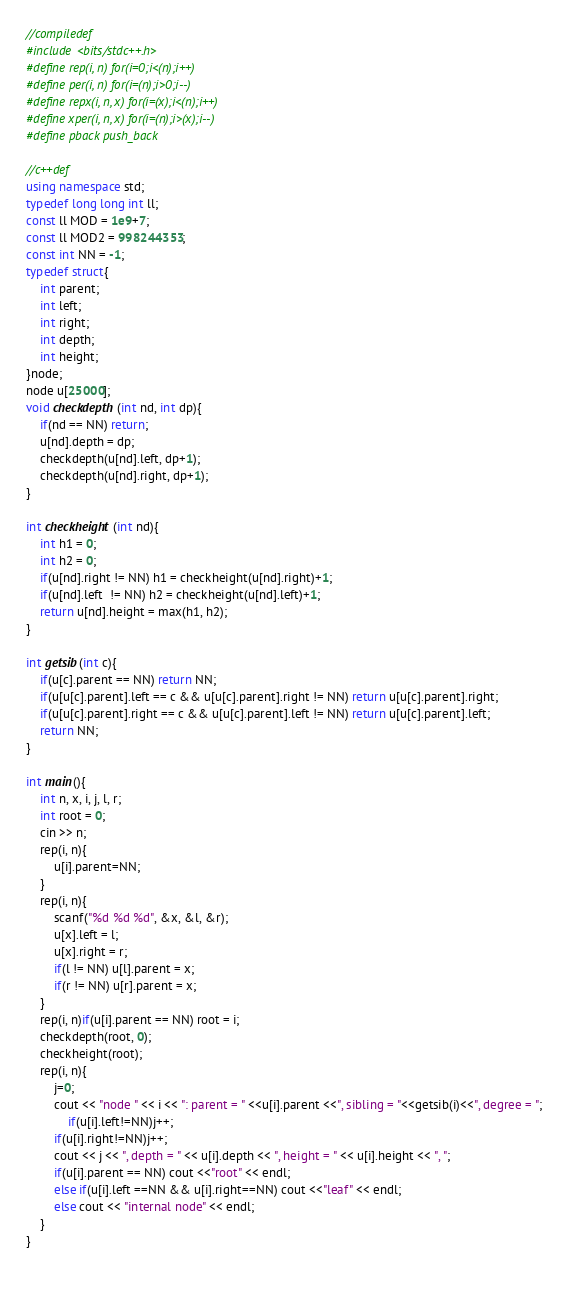Convert code to text. <code><loc_0><loc_0><loc_500><loc_500><_C++_>//compiledef
#include <bits/stdc++.h>
#define rep(i, n) for(i=0;i<(n);i++)
#define per(i, n) for(i=(n);i>0;i--)
#define repx(i, n, x) for(i=(x);i<(n);i++)
#define xper(i, n, x) for(i=(n);i>(x);i--)
#define pback push_back

//c++def
using namespace std;
typedef long long int ll;
const ll MOD = 1e9+7;
const ll MOD2 = 998244353;
const int NN = -1;
typedef struct{
	int parent;
	int left;
	int right;
	int depth;
	int height;
}node;
node u[25000];
void checkdepth(int nd, int dp){
	if(nd == NN) return;
	u[nd].depth = dp;
	checkdepth(u[nd].left, dp+1);
	checkdepth(u[nd].right, dp+1);
}

int checkheight(int nd){
	int h1 = 0;
	int h2 = 0;
	if(u[nd].right != NN) h1 = checkheight(u[nd].right)+1;
	if(u[nd].left  != NN) h2 = checkheight(u[nd].left)+1;
	return u[nd].height = max(h1, h2);
}

int getsib(int c){
	if(u[c].parent == NN) return NN;
	if(u[u[c].parent].left == c && u[u[c].parent].right != NN) return u[u[c].parent].right;
	if(u[u[c].parent].right == c && u[u[c].parent].left != NN) return u[u[c].parent].left;
	return NN;
}

int main(){
	int n, x, i, j, l, r;
	int root = 0;
	cin >> n;
	rep(i, n){
		u[i].parent=NN;
	}
	rep(i, n){
		scanf("%d %d %d", &x, &l, &r);
		u[x].left = l;
		u[x].right = r;
		if(l != NN) u[l].parent = x;
		if(r != NN) u[r].parent = x;
	}
	rep(i, n)if(u[i].parent == NN) root = i;
	checkdepth(root, 0);
	checkheight(root);
	rep(i, n){
		j=0;
		cout << "node " << i << ": parent = " <<u[i].parent <<", sibling = "<<getsib(i)<<", degree = ";
			if(u[i].left!=NN)j++;
		if(u[i].right!=NN)j++;
		cout << j << ", depth = " << u[i].depth << ", height = " << u[i].height << ", ";
		if(u[i].parent == NN) cout <<"root" << endl;
		else if(u[i].left ==NN && u[i].right==NN) cout <<"leaf" << endl;
		else cout << "internal node" << endl;
	}
}
		







</code> 